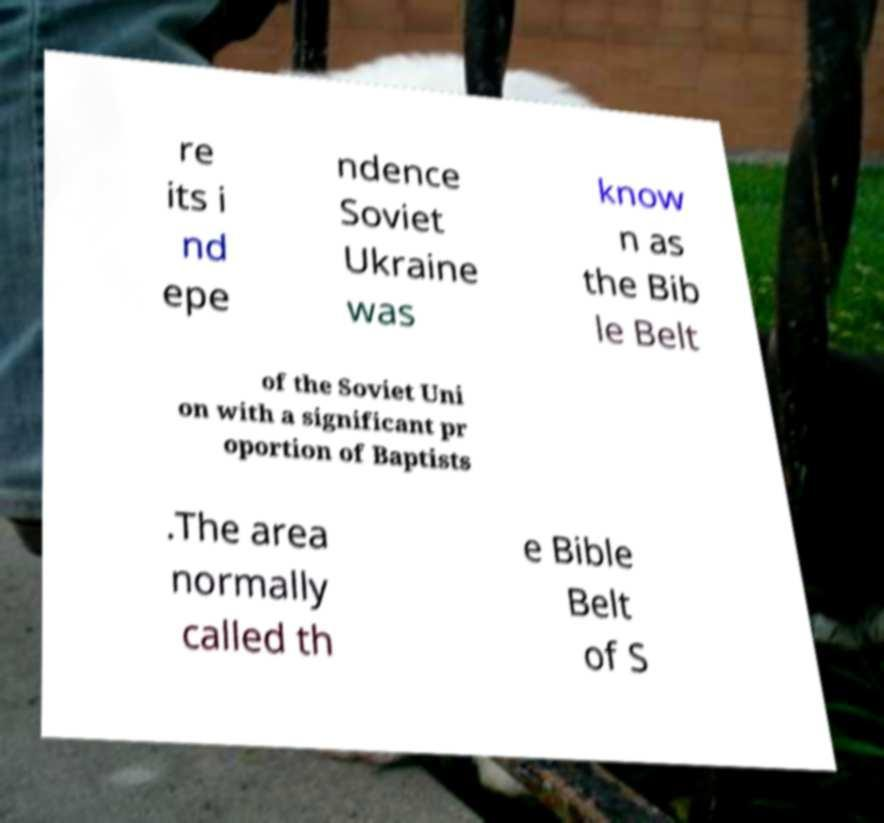Could you assist in decoding the text presented in this image and type it out clearly? re its i nd epe ndence Soviet Ukraine was know n as the Bib le Belt of the Soviet Uni on with a significant pr oportion of Baptists .The area normally called th e Bible Belt of S 